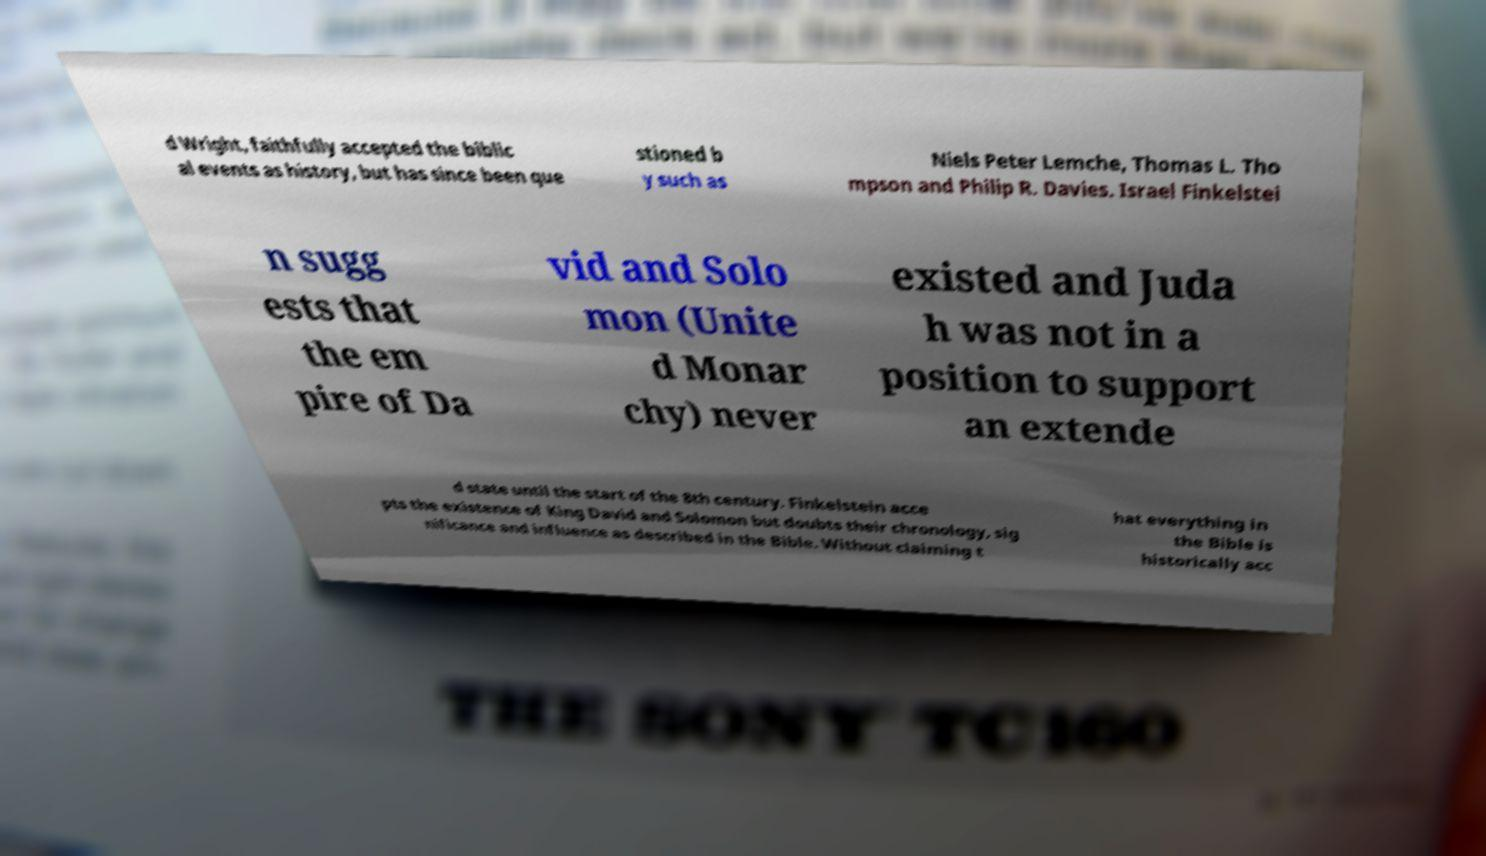Please identify and transcribe the text found in this image. d Wright, faithfully accepted the biblic al events as history, but has since been que stioned b y such as Niels Peter Lemche, Thomas L. Tho mpson and Philip R. Davies. Israel Finkelstei n sugg ests that the em pire of Da vid and Solo mon (Unite d Monar chy) never existed and Juda h was not in a position to support an extende d state until the start of the 8th century. Finkelstein acce pts the existence of King David and Solomon but doubts their chronology, sig nificance and influence as described in the Bible. Without claiming t hat everything in the Bible is historically acc 